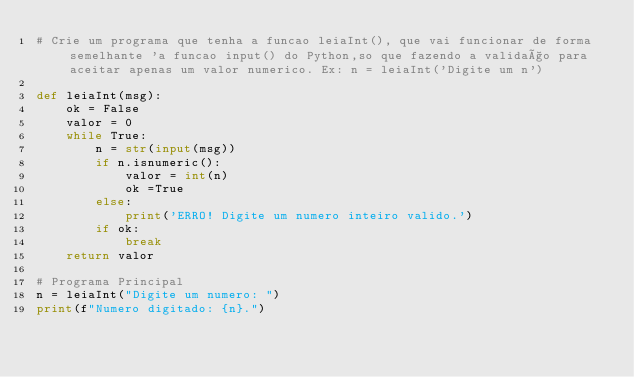<code> <loc_0><loc_0><loc_500><loc_500><_Python_># Crie um programa que tenha a funcao leiaInt(), que vai funcionar de forma semelhante 'a funcao input() do Python,so que fazendo a validaço para aceitar apenas um valor numerico. Ex: n = leiaInt('Digite um n')

def leiaInt(msg):
    ok = False
    valor = 0
    while True:
        n = str(input(msg))
        if n.isnumeric():
            valor = int(n)
            ok =True
        else:
            print('ERRO! Digite um numero inteiro valido.')
        if ok:
            break
    return valor

# Programa Principal
n = leiaInt("Digite um numero: ")
print(f"Numero digitado: {n}.")
</code> 